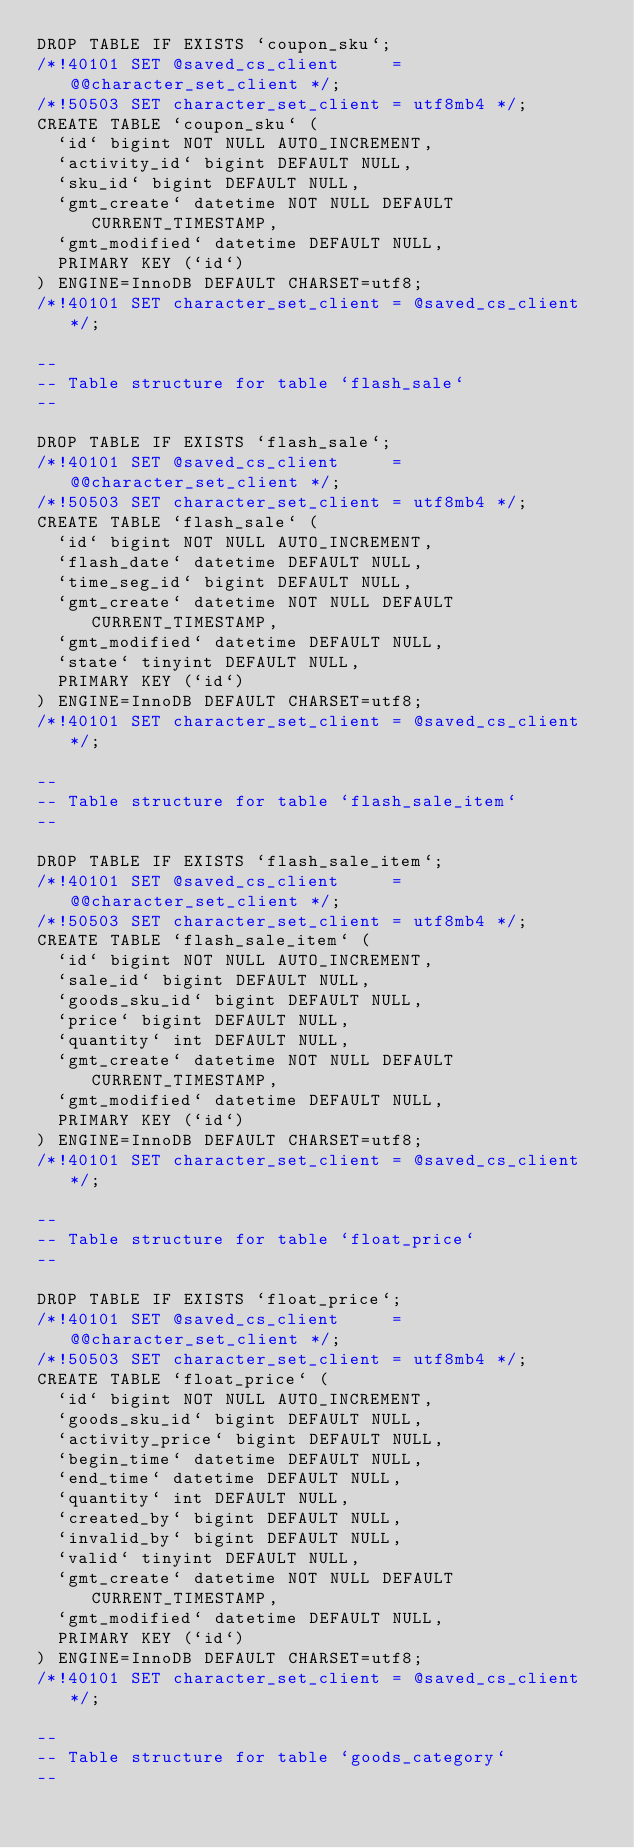<code> <loc_0><loc_0><loc_500><loc_500><_SQL_>DROP TABLE IF EXISTS `coupon_sku`;
/*!40101 SET @saved_cs_client     = @@character_set_client */;
/*!50503 SET character_set_client = utf8mb4 */;
CREATE TABLE `coupon_sku` (
  `id` bigint NOT NULL AUTO_INCREMENT,
  `activity_id` bigint DEFAULT NULL,
  `sku_id` bigint DEFAULT NULL,
  `gmt_create` datetime NOT NULL DEFAULT CURRENT_TIMESTAMP,
  `gmt_modified` datetime DEFAULT NULL,
  PRIMARY KEY (`id`)
) ENGINE=InnoDB DEFAULT CHARSET=utf8;
/*!40101 SET character_set_client = @saved_cs_client */;

--
-- Table structure for table `flash_sale`
--

DROP TABLE IF EXISTS `flash_sale`;
/*!40101 SET @saved_cs_client     = @@character_set_client */;
/*!50503 SET character_set_client = utf8mb4 */;
CREATE TABLE `flash_sale` (
  `id` bigint NOT NULL AUTO_INCREMENT,
  `flash_date` datetime DEFAULT NULL,
  `time_seg_id` bigint DEFAULT NULL,
  `gmt_create` datetime NOT NULL DEFAULT CURRENT_TIMESTAMP,
  `gmt_modified` datetime DEFAULT NULL,
  `state` tinyint DEFAULT NULL,
  PRIMARY KEY (`id`)
) ENGINE=InnoDB DEFAULT CHARSET=utf8;
/*!40101 SET character_set_client = @saved_cs_client */;

--
-- Table structure for table `flash_sale_item`
--

DROP TABLE IF EXISTS `flash_sale_item`;
/*!40101 SET @saved_cs_client     = @@character_set_client */;
/*!50503 SET character_set_client = utf8mb4 */;
CREATE TABLE `flash_sale_item` (
  `id` bigint NOT NULL AUTO_INCREMENT,
  `sale_id` bigint DEFAULT NULL,
  `goods_sku_id` bigint DEFAULT NULL,
  `price` bigint DEFAULT NULL,
  `quantity` int DEFAULT NULL,
  `gmt_create` datetime NOT NULL DEFAULT CURRENT_TIMESTAMP,
  `gmt_modified` datetime DEFAULT NULL,
  PRIMARY KEY (`id`)
) ENGINE=InnoDB DEFAULT CHARSET=utf8;
/*!40101 SET character_set_client = @saved_cs_client */;

--
-- Table structure for table `float_price`
--

DROP TABLE IF EXISTS `float_price`;
/*!40101 SET @saved_cs_client     = @@character_set_client */;
/*!50503 SET character_set_client = utf8mb4 */;
CREATE TABLE `float_price` (
  `id` bigint NOT NULL AUTO_INCREMENT,
  `goods_sku_id` bigint DEFAULT NULL,
  `activity_price` bigint DEFAULT NULL,
  `begin_time` datetime DEFAULT NULL,
  `end_time` datetime DEFAULT NULL,
  `quantity` int DEFAULT NULL,
  `created_by` bigint DEFAULT NULL,
  `invalid_by` bigint DEFAULT NULL,
  `valid` tinyint DEFAULT NULL,
  `gmt_create` datetime NOT NULL DEFAULT CURRENT_TIMESTAMP,
  `gmt_modified` datetime DEFAULT NULL,
  PRIMARY KEY (`id`)
) ENGINE=InnoDB DEFAULT CHARSET=utf8;
/*!40101 SET character_set_client = @saved_cs_client */;

--
-- Table structure for table `goods_category`
--
</code> 